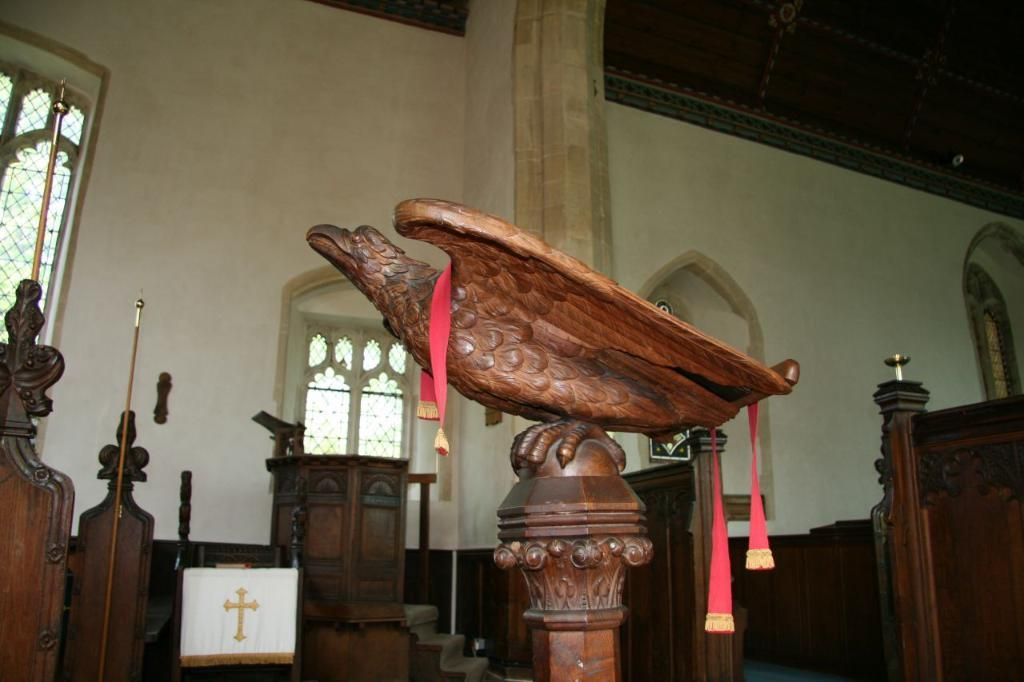What type of statue is in the image? There is a statue of a bird in the image. What color is the statue? The statue is brown in color. What can be seen in the background of the image? There is a podium and a window in the background of the image. What color is the wall in the background? The wall in the background is cream-colored. What subject is the statue teaching in the image? There is no indication in the image that the statue is teaching a subject, as it is a statue of a bird and not a living being. 